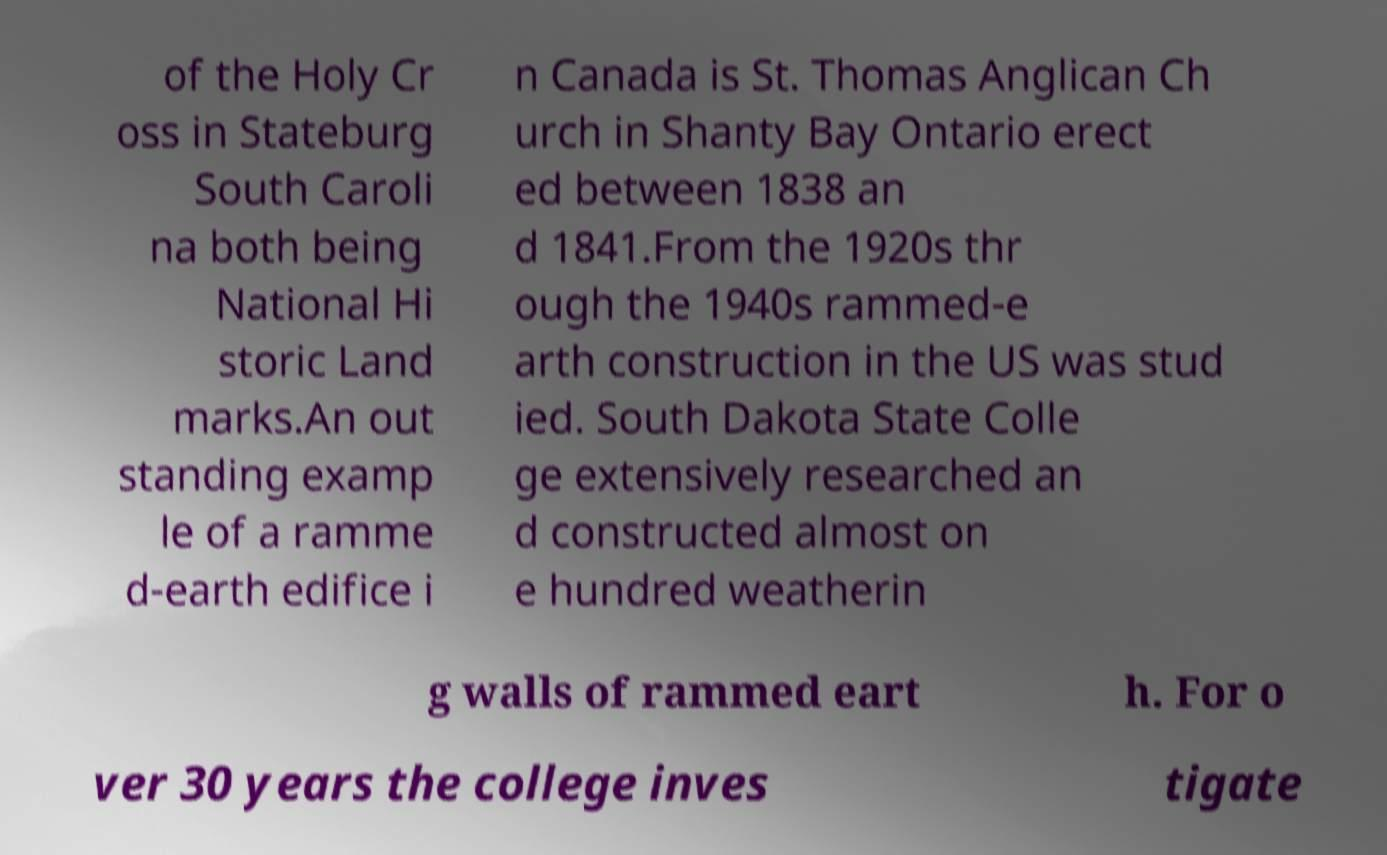Could you assist in decoding the text presented in this image and type it out clearly? of the Holy Cr oss in Stateburg South Caroli na both being National Hi storic Land marks.An out standing examp le of a ramme d-earth edifice i n Canada is St. Thomas Anglican Ch urch in Shanty Bay Ontario erect ed between 1838 an d 1841.From the 1920s thr ough the 1940s rammed-e arth construction in the US was stud ied. South Dakota State Colle ge extensively researched an d constructed almost on e hundred weatherin g walls of rammed eart h. For o ver 30 years the college inves tigate 